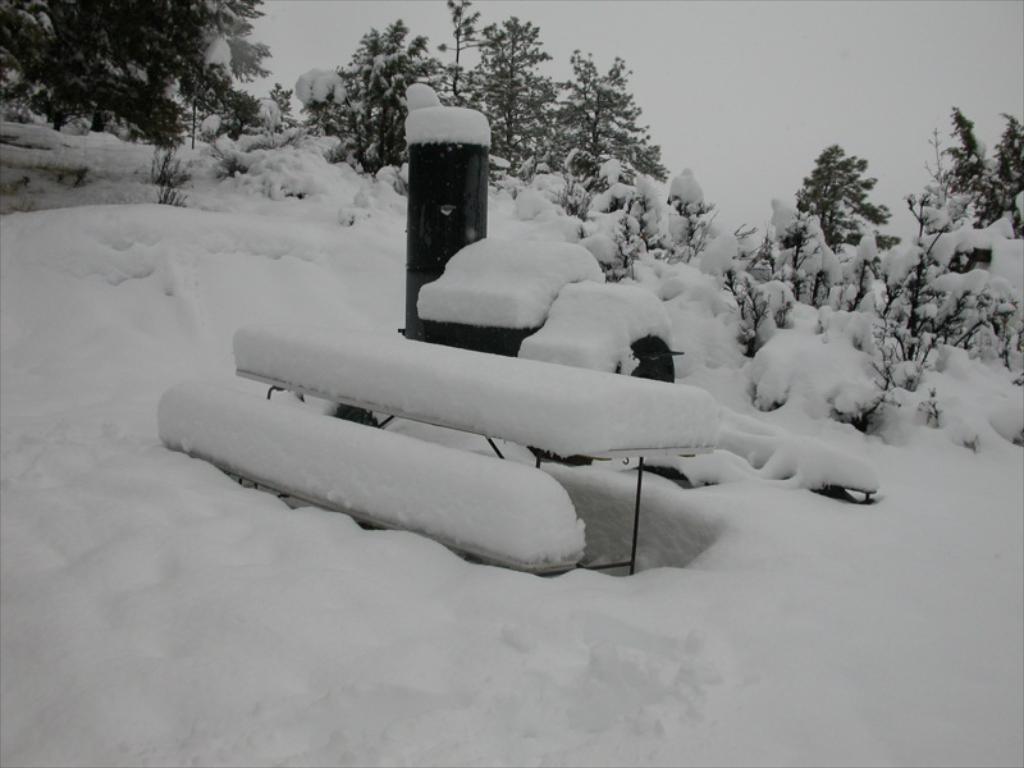In one or two sentences, can you explain what this image depicts? At the bottom of the picture, we see ice. In the middle of the picture, we see benches and an object in black color. These objects are covered with the ice. In the background, we see the trees which are covered with the ice. At the top, we see the sky. 